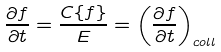<formula> <loc_0><loc_0><loc_500><loc_500>\frac { \partial f } { \partial t } = \frac { C \{ f \} } { E } = \left ( \frac { \partial f } { \partial t } \right ) _ { c o l l }</formula> 